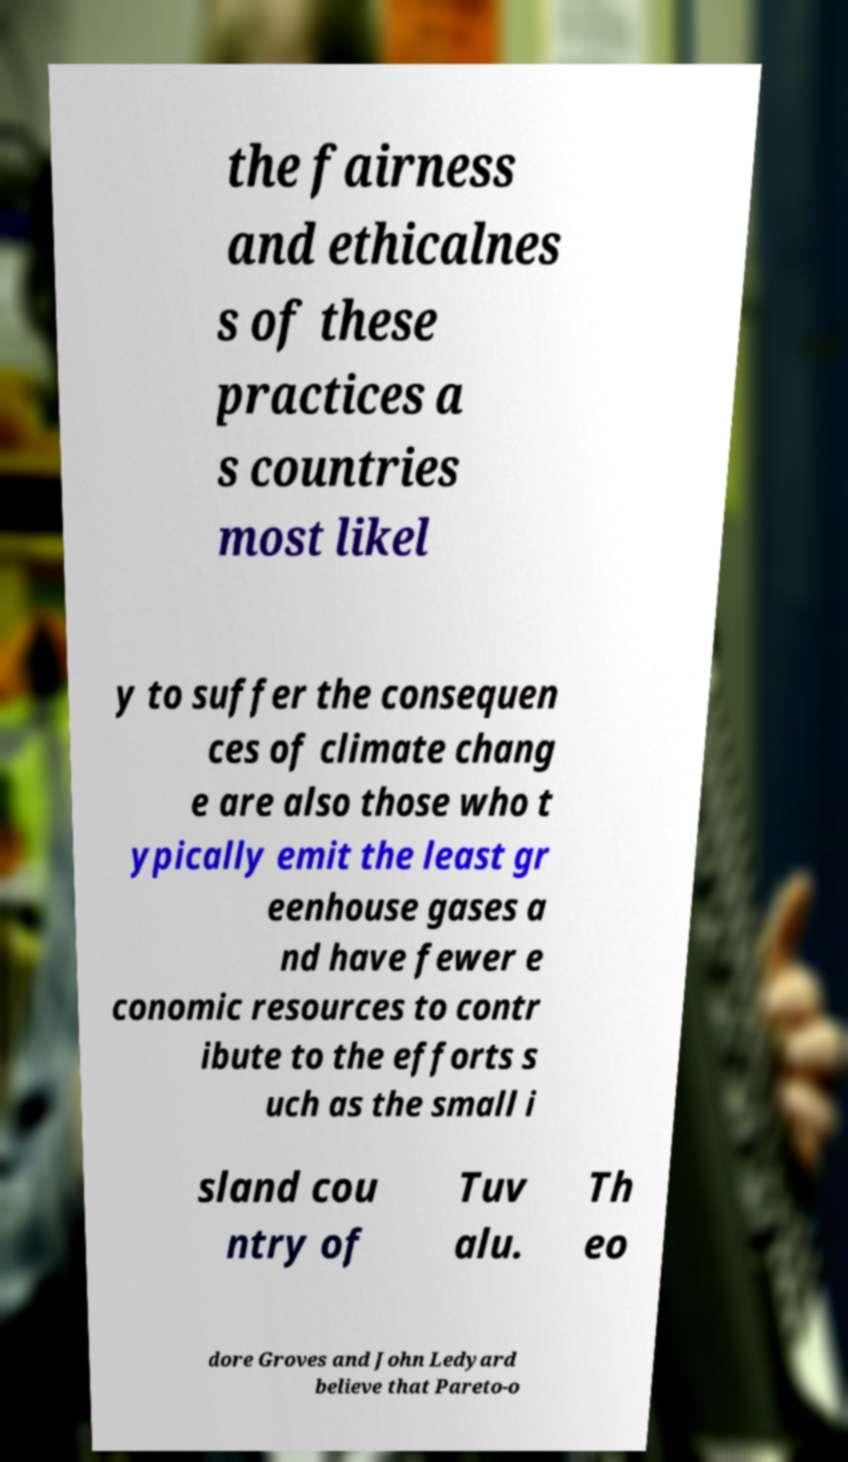Please read and relay the text visible in this image. What does it say? the fairness and ethicalnes s of these practices a s countries most likel y to suffer the consequen ces of climate chang e are also those who t ypically emit the least gr eenhouse gases a nd have fewer e conomic resources to contr ibute to the efforts s uch as the small i sland cou ntry of Tuv alu. Th eo dore Groves and John Ledyard believe that Pareto-o 